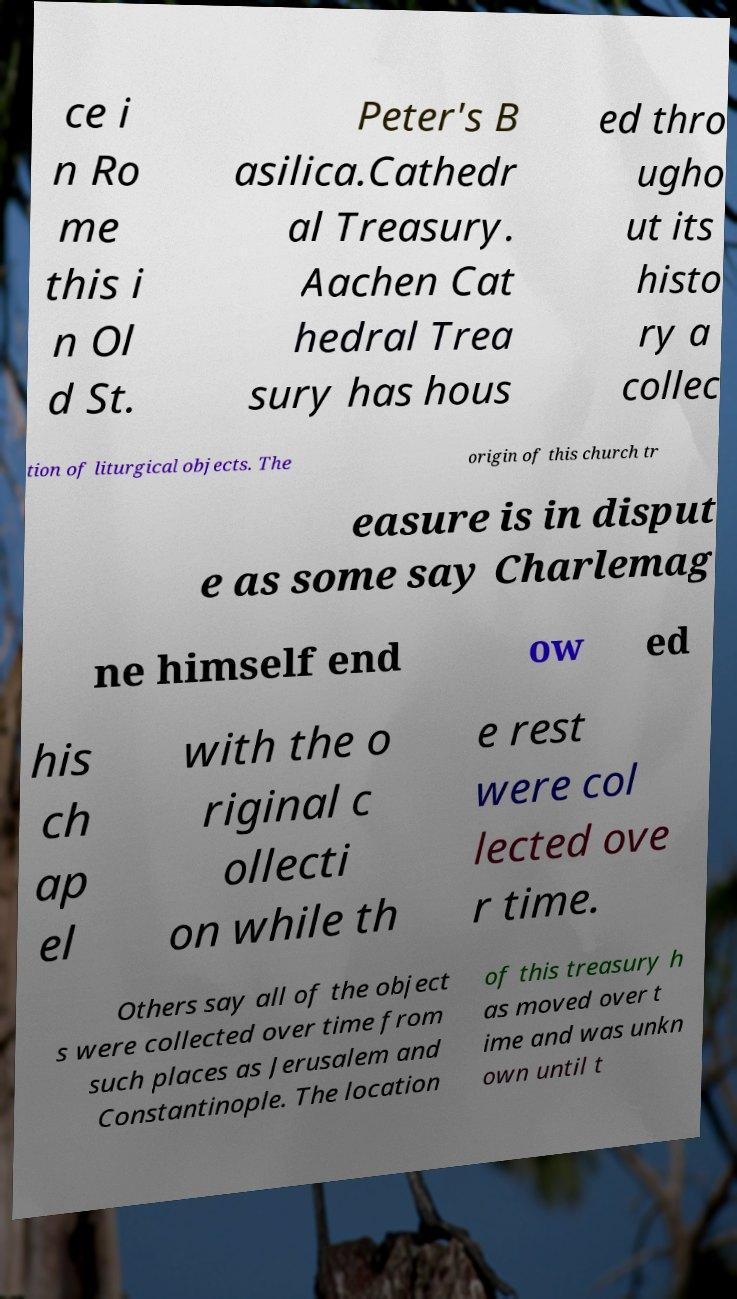Please identify and transcribe the text found in this image. ce i n Ro me this i n Ol d St. Peter's B asilica.Cathedr al Treasury. Aachen Cat hedral Trea sury has hous ed thro ugho ut its histo ry a collec tion of liturgical objects. The origin of this church tr easure is in disput e as some say Charlemag ne himself end ow ed his ch ap el with the o riginal c ollecti on while th e rest were col lected ove r time. Others say all of the object s were collected over time from such places as Jerusalem and Constantinople. The location of this treasury h as moved over t ime and was unkn own until t 